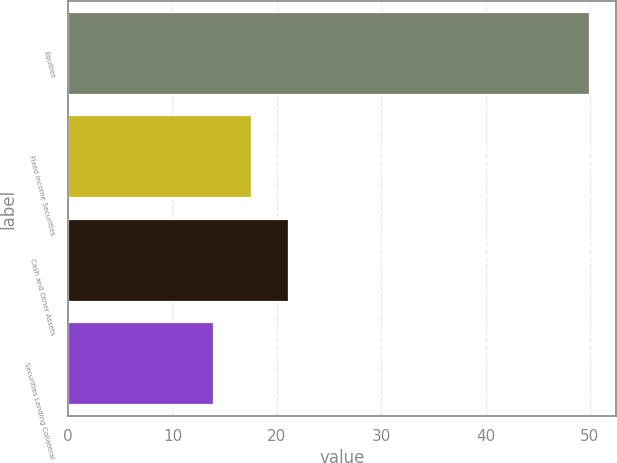Convert chart to OTSL. <chart><loc_0><loc_0><loc_500><loc_500><bar_chart><fcel>Equities<fcel>Fixed Income Securities<fcel>Cash and Other Assets<fcel>Securities Lending Collateral<nl><fcel>50<fcel>17.6<fcel>21.2<fcel>14<nl></chart> 